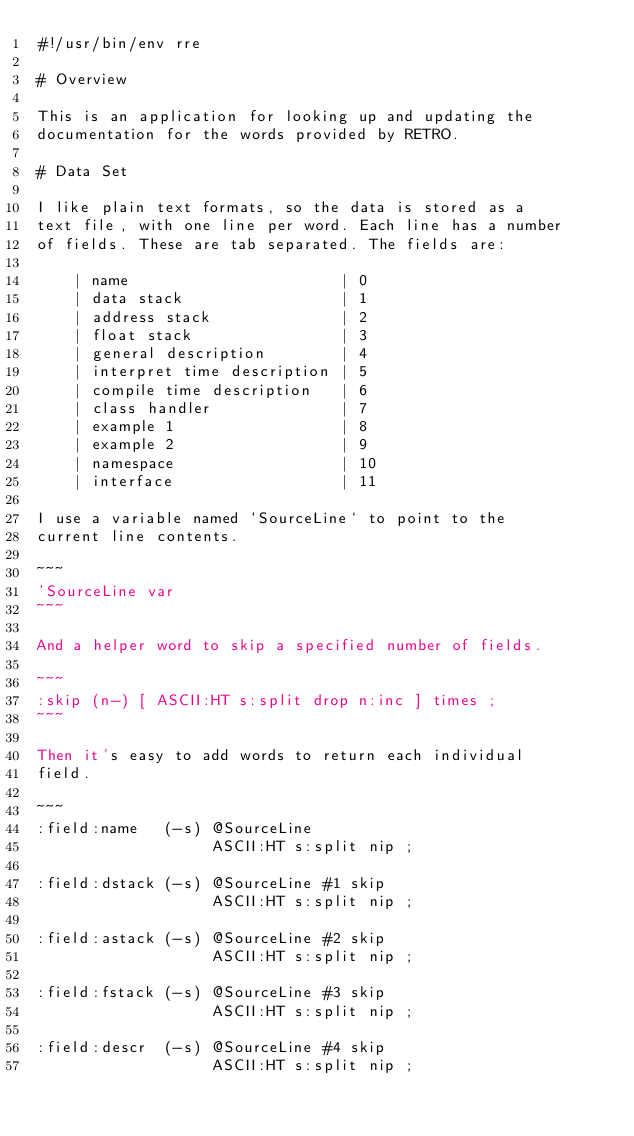<code> <loc_0><loc_0><loc_500><loc_500><_Forth_>#!/usr/bin/env rre

# Overview

This is an application for looking up and updating the
documentation for the words provided by RETRO.

# Data Set

I like plain text formats, so the data is stored as a
text file, with one line per word. Each line has a number
of fields. These are tab separated. The fields are:

    | name                       | 0
    | data stack                 | 1
    | address stack              | 2
    | float stack                | 3
    | general description        | 4
    | interpret time description | 5
    | compile time description   | 6
    | class handler              | 7
    | example 1                  | 8
    | example 2                  | 9
    | namespace                  | 10
    | interface                  | 11

I use a variable named `SourceLine` to point to the
current line contents.

~~~
'SourceLine var
~~~

And a helper word to skip a specified number of fields.

~~~
:skip (n-) [ ASCII:HT s:split drop n:inc ] times ;
~~~

Then it's easy to add words to return each individual
field.

~~~
:field:name   (-s) @SourceLine
                   ASCII:HT s:split nip ;

:field:dstack (-s) @SourceLine #1 skip
                   ASCII:HT s:split nip ;

:field:astack (-s) @SourceLine #2 skip
                   ASCII:HT s:split nip ;

:field:fstack (-s) @SourceLine #3 skip
                   ASCII:HT s:split nip ;

:field:descr  (-s) @SourceLine #4 skip
                   ASCII:HT s:split nip ;
</code> 